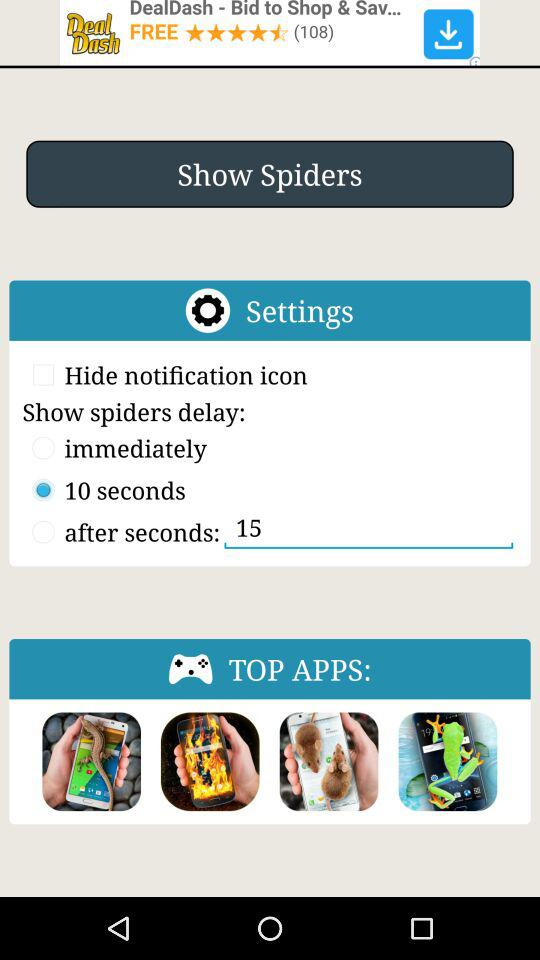Which radio button is selected? The selected radio button is "10 seconds". 